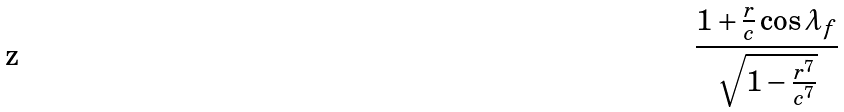<formula> <loc_0><loc_0><loc_500><loc_500>\frac { 1 + \frac { r } { c } \cos \lambda _ { f } } { \sqrt { 1 - \frac { r ^ { 7 } } { c ^ { 7 } } } }</formula> 